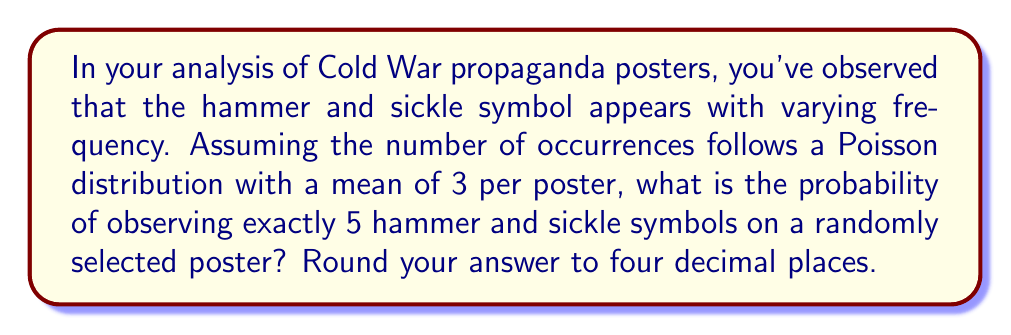Provide a solution to this math problem. Let's approach this step-by-step:

1) The Poisson distribution is given by the formula:

   $$P(X = k) = \frac{e^{-\lambda} \lambda^k}{k!}$$

   Where:
   $\lambda$ is the mean number of occurrences
   $k$ is the number of occurrences we're interested in
   $e$ is Euler's number (approximately 2.71828)

2) In this case:
   $\lambda = 3$ (mean occurrences per poster)
   $k = 5$ (we're looking for exactly 5 occurrences)

3) Let's substitute these values into the formula:

   $$P(X = 5) = \frac{e^{-3} 3^5}{5!}$$

4) Now, let's calculate step by step:

   $$P(X = 5) = \frac{e^{-3} \cdot 3^5}{5 \cdot 4 \cdot 3 \cdot 2 \cdot 1}$$

5) Calculate $e^{-3}$:
   $e^{-3} \approx 0.0497870684$

6) Calculate $3^5$:
   $3^5 = 243$

7) Calculate $5!$:
   $5! = 120$

8) Now, put it all together:

   $$P(X = 5) = \frac{0.0497870684 \cdot 243}{120} \approx 0.1008$$

9) Rounding to four decimal places:

   $P(X = 5) \approx 0.1008$

This means there's approximately a 10.08% chance of observing exactly 5 hammer and sickle symbols on a randomly selected poster, given the assumed Poisson distribution.
Answer: 0.1008 